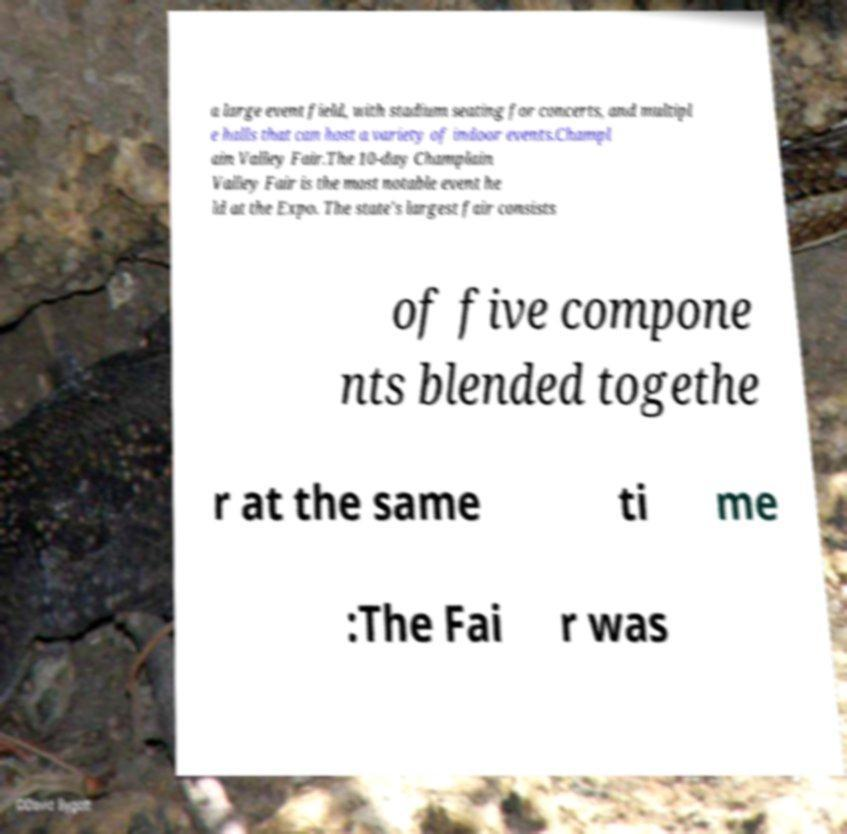Can you accurately transcribe the text from the provided image for me? a large event field, with stadium seating for concerts, and multipl e halls that can host a variety of indoor events.Champl ain Valley Fair.The 10-day Champlain Valley Fair is the most notable event he ld at the Expo. The state's largest fair consists of five compone nts blended togethe r at the same ti me :The Fai r was 